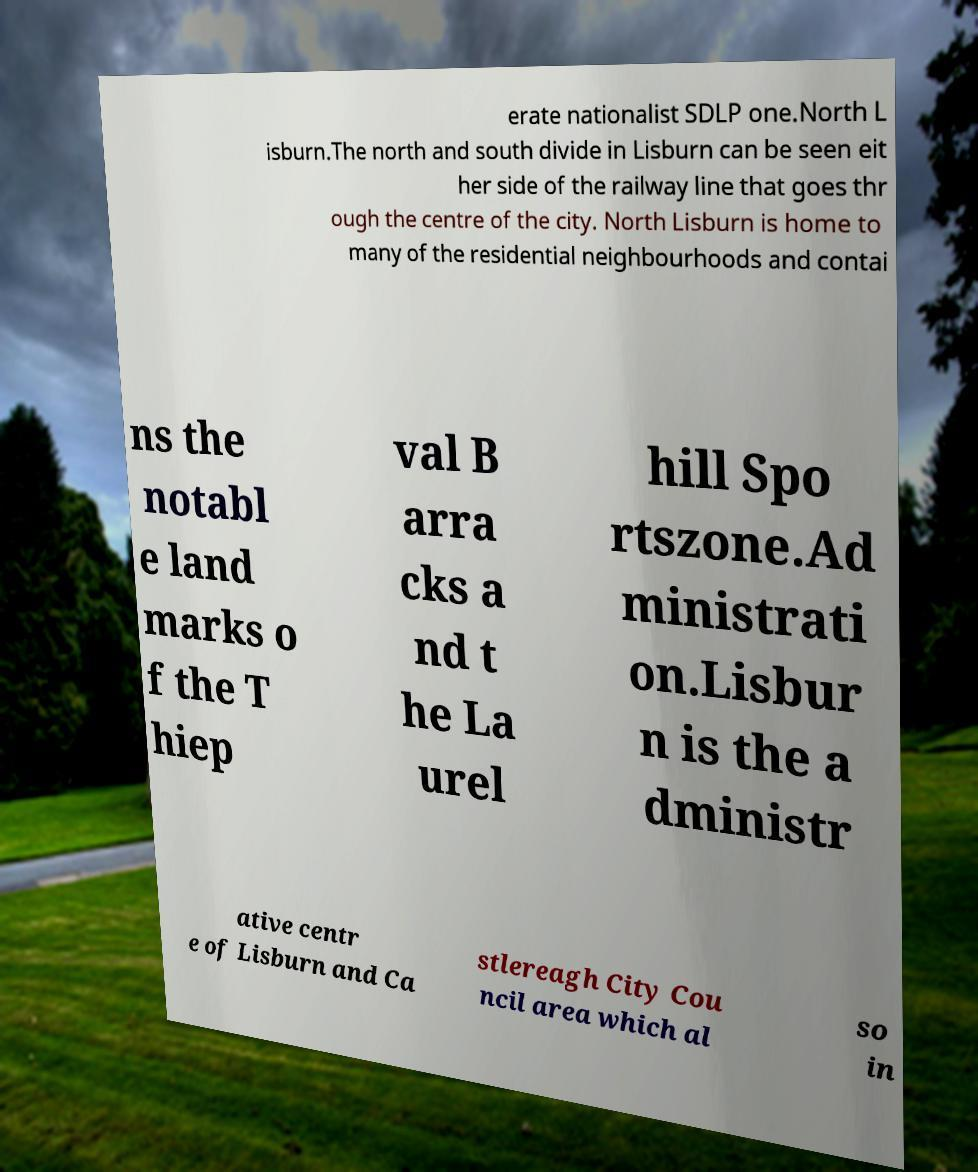Could you assist in decoding the text presented in this image and type it out clearly? erate nationalist SDLP one.North L isburn.The north and south divide in Lisburn can be seen eit her side of the railway line that goes thr ough the centre of the city. North Lisburn is home to many of the residential neighbourhoods and contai ns the notabl e land marks o f the T hiep val B arra cks a nd t he La urel hill Spo rtszone.Ad ministrati on.Lisbur n is the a dministr ative centr e of Lisburn and Ca stlereagh City Cou ncil area which al so in 